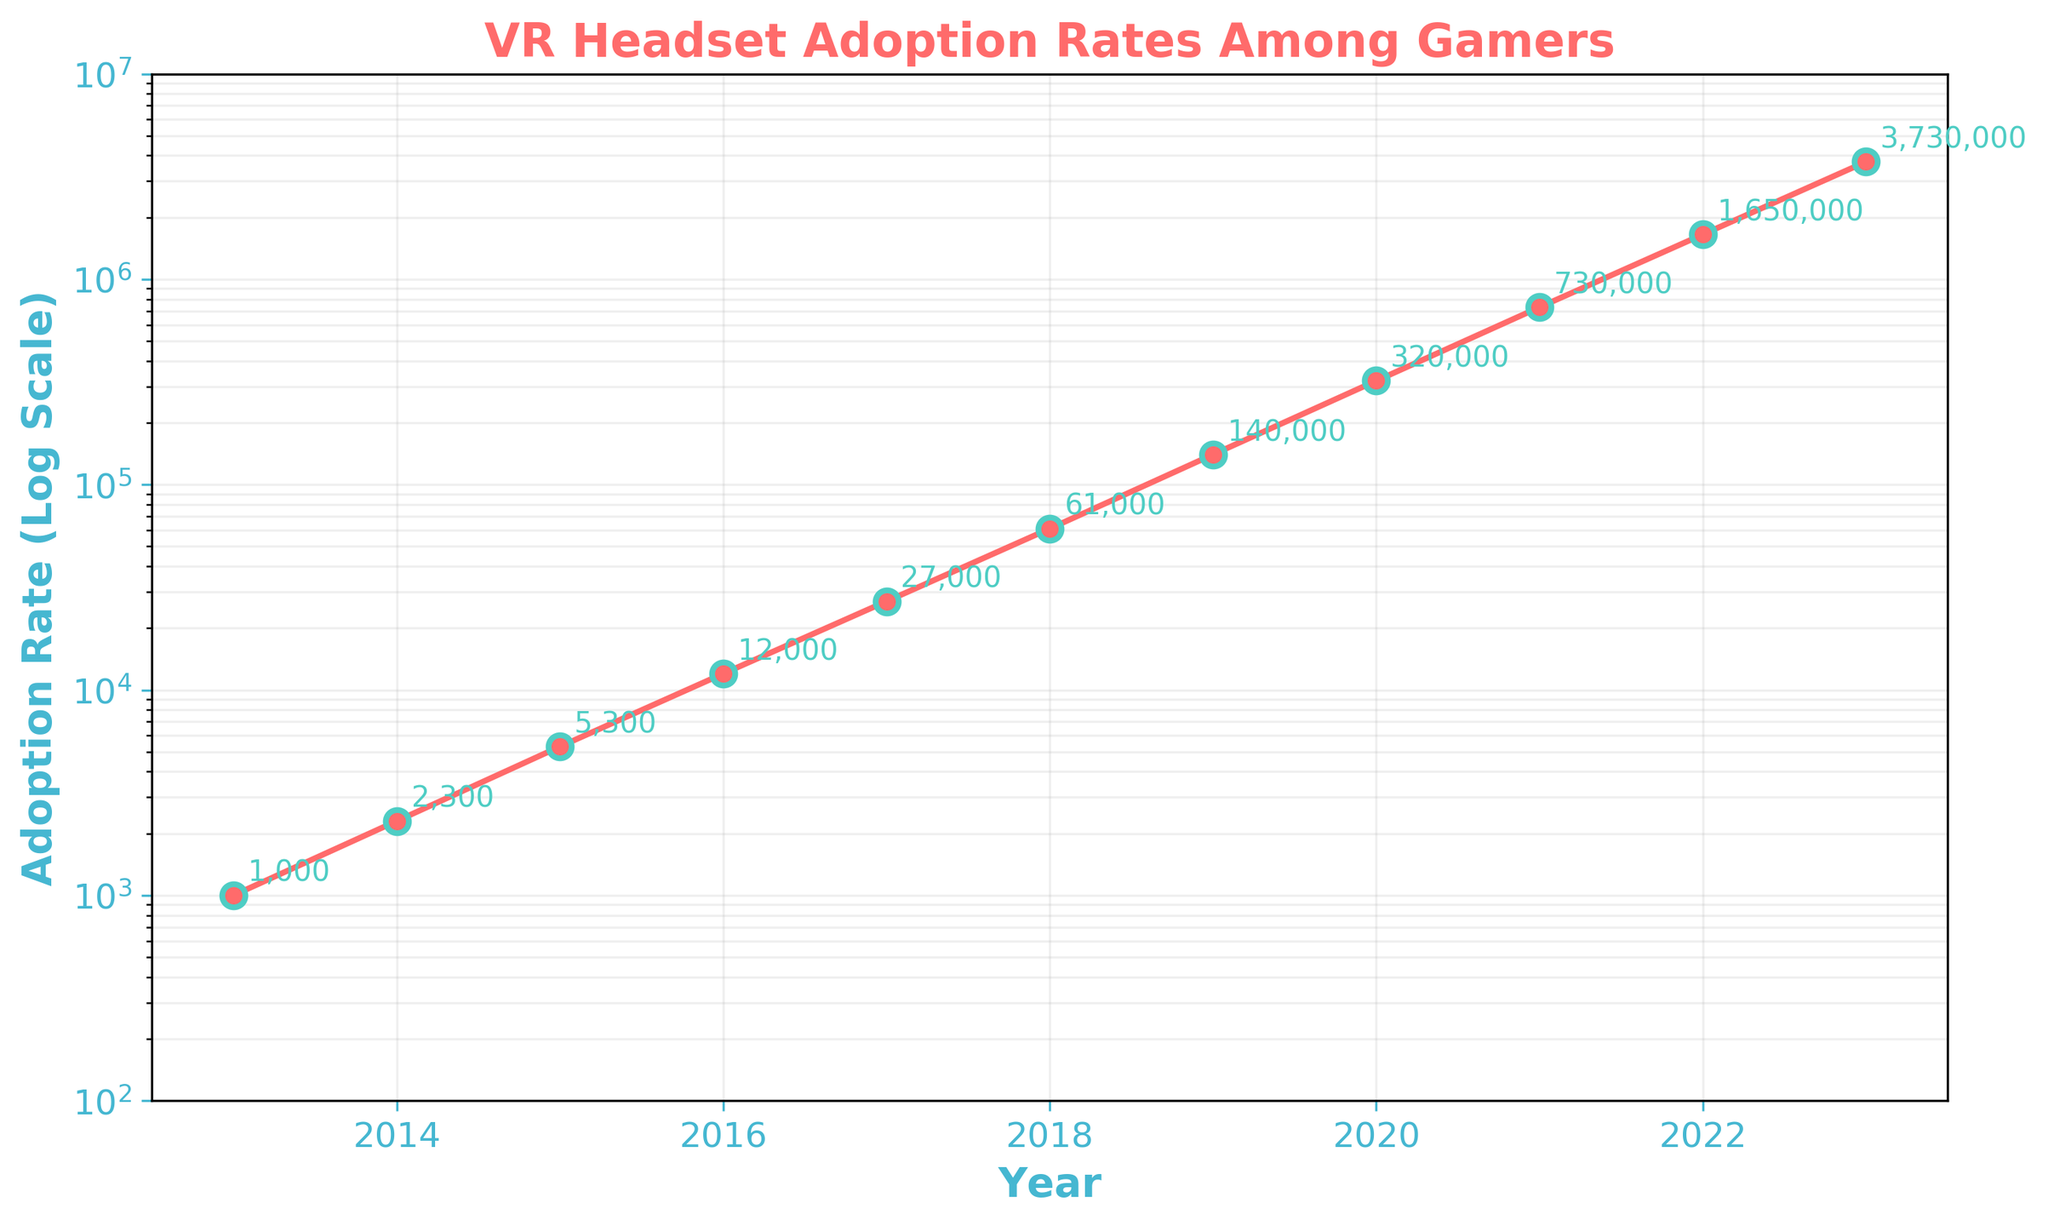what is the title of the plot? The title of the plot is prominently displayed at the top and reads "VR Headset Adoption Rates Among Gamers".
Answer: VR Headset Adoption Rates Among Gamers How many data points are shown in the plot? The plot displays one data point for each year from 2013 to 2023, making a total of 11 data points.
Answer: 11 what is the adoption rate in 2023? Look for the data point corresponding to the year 2023 on the x-axis and read the value off the y-axis. The adoption rate for 2023 is around 3,730,000.
Answer: 3,730,000 By how much did the adoption rate increase from 2020 to 2023? Find the adoption rates for the years 2020 and 2023 (320,000 and 3,730,000, respectively). Subtract the 2020 rate from the 2023 rate: 3,730,000 - 320,000 = 3,410,000.
Answer: 3,410,000 During which year did the adoption rate first exceed 1,000,000? Find the point where the plotted line first crosses the 1,000,000 mark on the y-axis, which corresponds to the year 2021.
Answer: 2021 How much did the adoption rate increase between the years 2018 and 2019? The adoption rates for 2018 and 2019 are 61,000 and 140,000, respectively. Subtract the 2018 rate from the 2019 rate: 140,000 - 61,000 = 79,000.
Answer: 79,000 What is the slope of the line between 2016 and 2017 on the log scale axis? Find the adoption rates for 2016 and 2017 (12,000 and 27,000, respectively). The slope on a log scale can be approximated by log(27,000) - log(12,000): log10(27,000) = 4.43, log10(12,000) = 4.08; the difference is approximately 0.35.
Answer: 0.35 Is the adoption rate growth more rapid between 2013 and 2018, or between 2018 and 2023? Compare the rate of increase for each time period: from 2013 to 2018 (1,000 to 61,000, a change of 60,000) and from 2018 to 2023 (61,000 to 3,730,000, a change of 3,669,000). The adoption rate grew more rapidly between 2018 and 2023.
Answer: Between 2018 and 2023 What is the primary visual way the log scale affects the appearance of the plot? The log scale compresses the large range of adoption rates, making exponential growth appear as a straight line, which highlights growth trends more clearly than a linear scale.
Answer: It compresses large ranges and linearizes exponential growth Which two consecutive years show the largest increase in adoption rate? Review the consecutive years’ adoption rates and find the largest difference: the largest increase is between 2022 and 2023, where the rate goes from 1,650,000 to 3,730,000, an increase of 2,080,000.
Answer: Between 2022 and 2023 